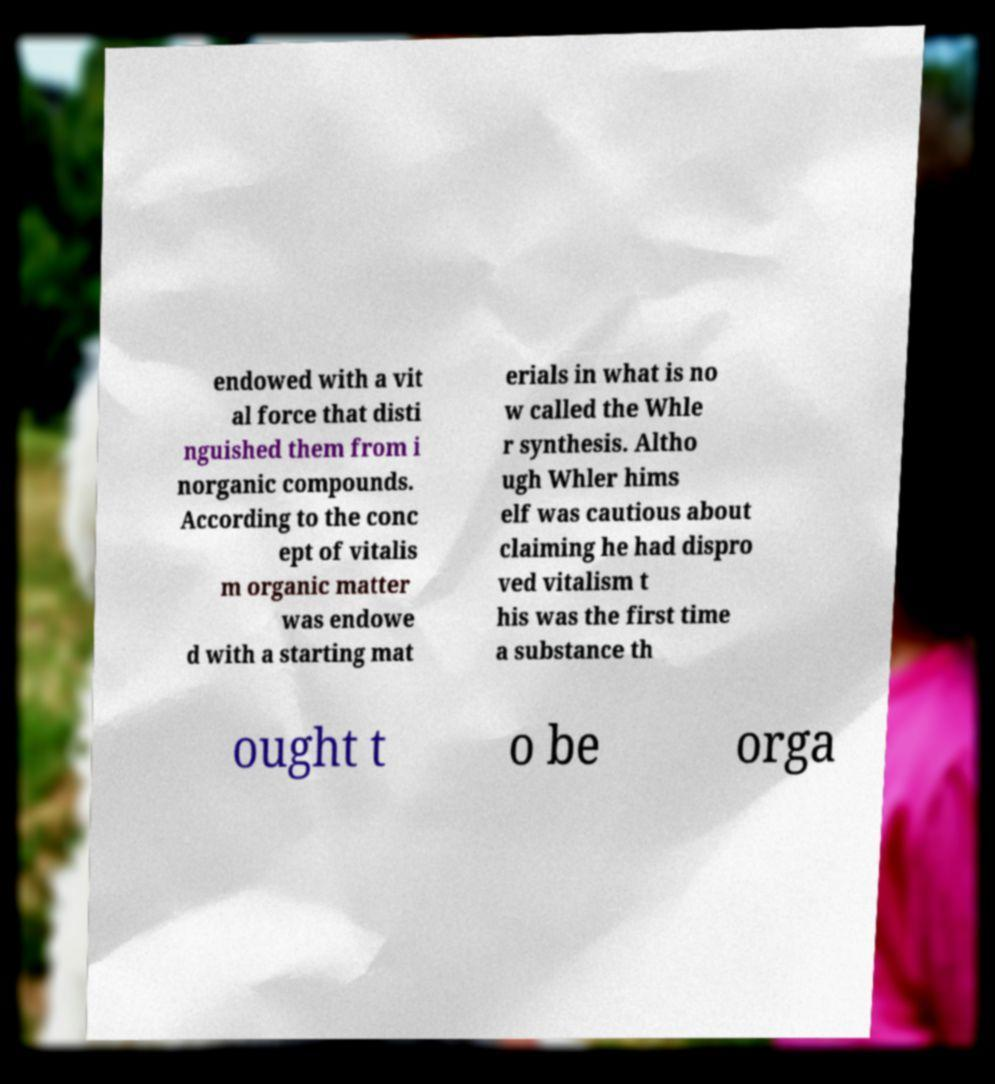Please identify and transcribe the text found in this image. endowed with a vit al force that disti nguished them from i norganic compounds. According to the conc ept of vitalis m organic matter was endowe d with a starting mat erials in what is no w called the Whle r synthesis. Altho ugh Whler hims elf was cautious about claiming he had dispro ved vitalism t his was the first time a substance th ought t o be orga 